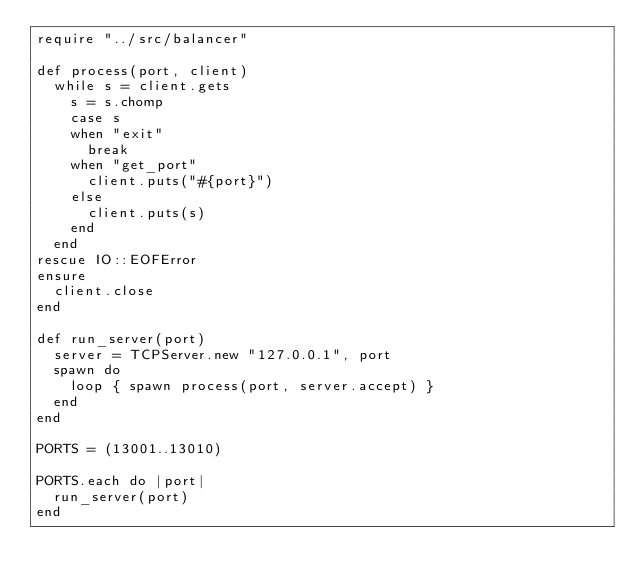<code> <loc_0><loc_0><loc_500><loc_500><_Crystal_>require "../src/balancer"

def process(port, client)
  while s = client.gets
    s = s.chomp
    case s
    when "exit"
      break
    when "get_port"
      client.puts("#{port}")
    else
      client.puts(s)
    end
  end
rescue IO::EOFError
ensure
  client.close
end

def run_server(port)
  server = TCPServer.new "127.0.0.1", port
  spawn do
    loop { spawn process(port, server.accept) }
  end
end

PORTS = (13001..13010)

PORTS.each do |port|
  run_server(port)
end
</code> 